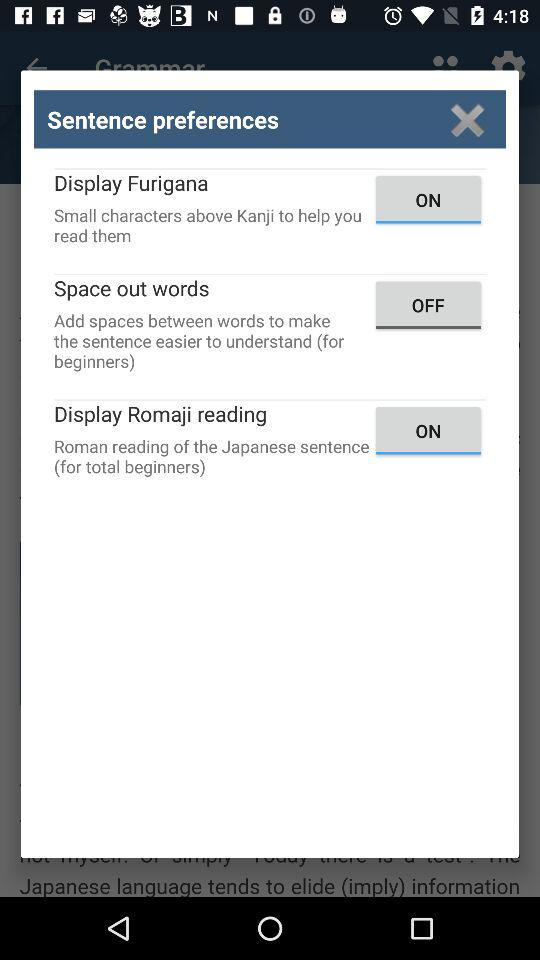What is the status of "Display Romaji reading"? The status of "Display Romaji reading" is "on". 